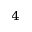<formula> <loc_0><loc_0><loc_500><loc_500>_ { 4 }</formula> 